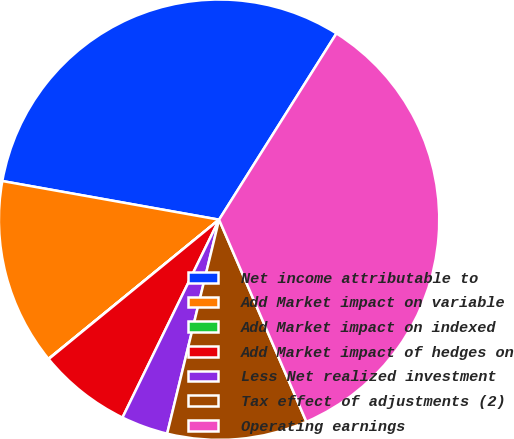Convert chart. <chart><loc_0><loc_0><loc_500><loc_500><pie_chart><fcel>Net income attributable to<fcel>Add Market impact on variable<fcel>Add Market impact on indexed<fcel>Add Market impact of hedges on<fcel>Less Net realized investment<fcel>Tax effect of adjustments (2)<fcel>Operating earnings<nl><fcel>31.14%<fcel>13.7%<fcel>0.02%<fcel>6.86%<fcel>3.44%<fcel>10.28%<fcel>34.56%<nl></chart> 